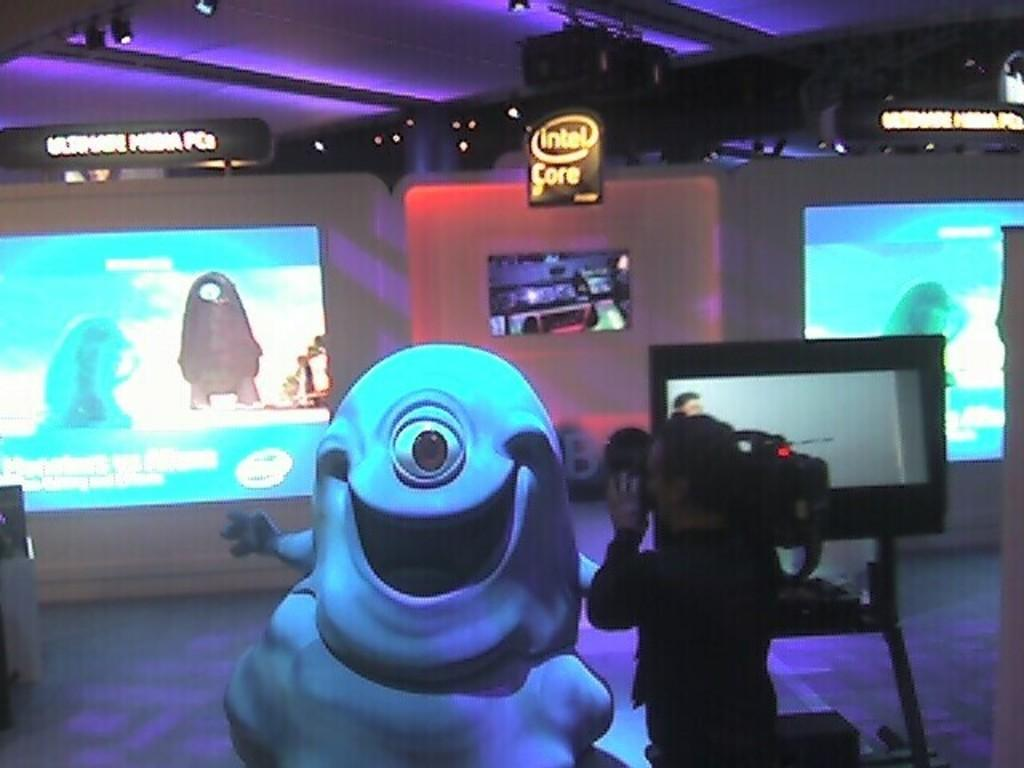What object can be seen in the image that is not a person? There is a toy in the image. What is the person in the image doing? The person is standing in the image and holding a video camera in their hands. What is the person wearing in the image? The person is wearing clothes in the image. What can be seen on the screens in the image? The screens are visible in the image, but the content cannot be determined from the provided facts. What is the surface beneath the person and the toy in the image? There is a floor in the image. What type of uncle is present in the image? There is no uncle present in the image. What is the weight of the toy on the scale in the image? There is no scale present in the image, and therefore no weight can be determined. 